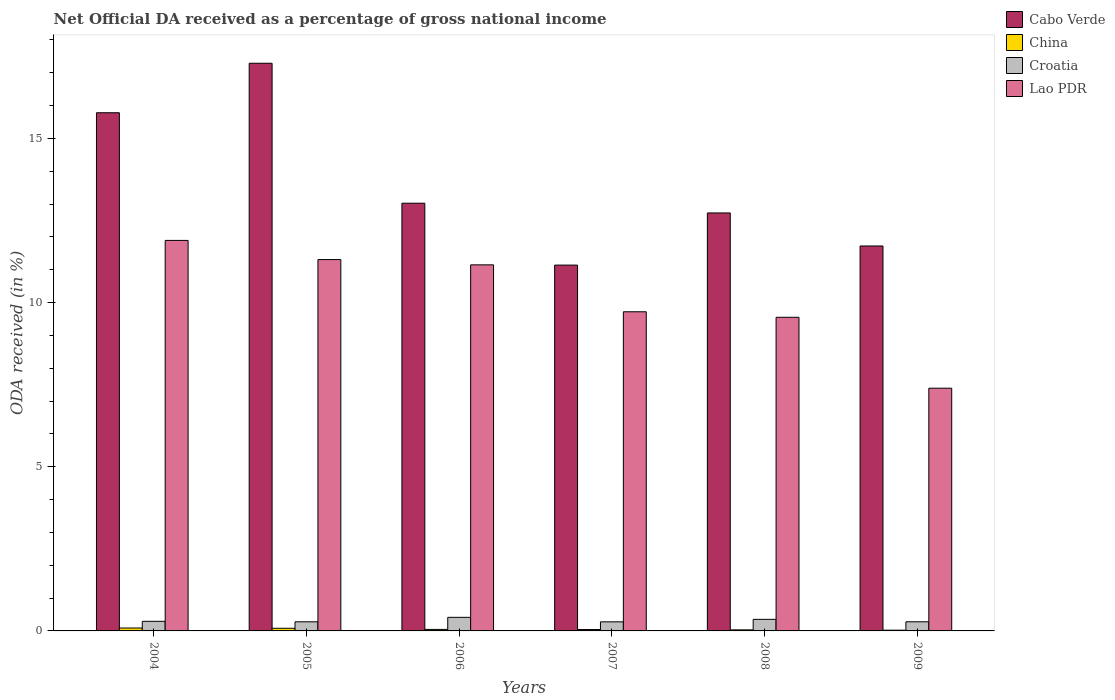How many different coloured bars are there?
Keep it short and to the point. 4. How many groups of bars are there?
Ensure brevity in your answer.  6. Are the number of bars per tick equal to the number of legend labels?
Your answer should be compact. Yes. How many bars are there on the 6th tick from the left?
Keep it short and to the point. 4. How many bars are there on the 3rd tick from the right?
Your response must be concise. 4. What is the label of the 5th group of bars from the left?
Provide a short and direct response. 2008. In how many cases, is the number of bars for a given year not equal to the number of legend labels?
Give a very brief answer. 0. What is the net official DA received in Cabo Verde in 2005?
Your answer should be very brief. 17.29. Across all years, what is the maximum net official DA received in Croatia?
Give a very brief answer. 0.41. Across all years, what is the minimum net official DA received in Croatia?
Offer a terse response. 0.28. What is the total net official DA received in Cabo Verde in the graph?
Keep it short and to the point. 81.69. What is the difference between the net official DA received in Lao PDR in 2006 and that in 2009?
Your answer should be very brief. 3.76. What is the difference between the net official DA received in China in 2005 and the net official DA received in Croatia in 2006?
Your response must be concise. -0.33. What is the average net official DA received in China per year?
Offer a terse response. 0.05. In the year 2004, what is the difference between the net official DA received in Croatia and net official DA received in Lao PDR?
Offer a terse response. -11.6. What is the ratio of the net official DA received in China in 2005 to that in 2008?
Keep it short and to the point. 2.5. Is the difference between the net official DA received in Croatia in 2008 and 2009 greater than the difference between the net official DA received in Lao PDR in 2008 and 2009?
Make the answer very short. No. What is the difference between the highest and the second highest net official DA received in China?
Offer a very short reply. 0.01. What is the difference between the highest and the lowest net official DA received in Lao PDR?
Ensure brevity in your answer.  4.5. In how many years, is the net official DA received in Lao PDR greater than the average net official DA received in Lao PDR taken over all years?
Ensure brevity in your answer.  3. Is the sum of the net official DA received in China in 2005 and 2007 greater than the maximum net official DA received in Lao PDR across all years?
Ensure brevity in your answer.  No. What does the 1st bar from the left in 2007 represents?
Your answer should be compact. Cabo Verde. What does the 4th bar from the right in 2004 represents?
Provide a succinct answer. Cabo Verde. What is the difference between two consecutive major ticks on the Y-axis?
Ensure brevity in your answer.  5. Are the values on the major ticks of Y-axis written in scientific E-notation?
Provide a succinct answer. No. Does the graph contain any zero values?
Make the answer very short. No. Does the graph contain grids?
Provide a short and direct response. No. Where does the legend appear in the graph?
Offer a terse response. Top right. How many legend labels are there?
Your answer should be compact. 4. What is the title of the graph?
Your response must be concise. Net Official DA received as a percentage of gross national income. What is the label or title of the X-axis?
Your response must be concise. Years. What is the label or title of the Y-axis?
Provide a short and direct response. ODA received (in %). What is the ODA received (in %) of Cabo Verde in 2004?
Offer a very short reply. 15.78. What is the ODA received (in %) in China in 2004?
Offer a very short reply. 0.09. What is the ODA received (in %) in Croatia in 2004?
Offer a very short reply. 0.29. What is the ODA received (in %) in Lao PDR in 2004?
Ensure brevity in your answer.  11.89. What is the ODA received (in %) in Cabo Verde in 2005?
Provide a short and direct response. 17.29. What is the ODA received (in %) of China in 2005?
Offer a terse response. 0.08. What is the ODA received (in %) of Croatia in 2005?
Keep it short and to the point. 0.28. What is the ODA received (in %) of Lao PDR in 2005?
Your answer should be compact. 11.31. What is the ODA received (in %) in Cabo Verde in 2006?
Ensure brevity in your answer.  13.03. What is the ODA received (in %) of China in 2006?
Keep it short and to the point. 0.05. What is the ODA received (in %) in Croatia in 2006?
Offer a very short reply. 0.41. What is the ODA received (in %) in Lao PDR in 2006?
Make the answer very short. 11.15. What is the ODA received (in %) in Cabo Verde in 2007?
Provide a short and direct response. 11.14. What is the ODA received (in %) of China in 2007?
Your answer should be compact. 0.04. What is the ODA received (in %) in Croatia in 2007?
Make the answer very short. 0.28. What is the ODA received (in %) in Lao PDR in 2007?
Your answer should be very brief. 9.72. What is the ODA received (in %) in Cabo Verde in 2008?
Offer a very short reply. 12.73. What is the ODA received (in %) in China in 2008?
Make the answer very short. 0.03. What is the ODA received (in %) in Croatia in 2008?
Provide a succinct answer. 0.35. What is the ODA received (in %) in Lao PDR in 2008?
Provide a short and direct response. 9.55. What is the ODA received (in %) of Cabo Verde in 2009?
Offer a very short reply. 11.72. What is the ODA received (in %) in China in 2009?
Your answer should be very brief. 0.02. What is the ODA received (in %) in Croatia in 2009?
Your answer should be very brief. 0.28. What is the ODA received (in %) in Lao PDR in 2009?
Provide a short and direct response. 7.39. Across all years, what is the maximum ODA received (in %) of Cabo Verde?
Offer a very short reply. 17.29. Across all years, what is the maximum ODA received (in %) in China?
Offer a very short reply. 0.09. Across all years, what is the maximum ODA received (in %) of Croatia?
Provide a succinct answer. 0.41. Across all years, what is the maximum ODA received (in %) of Lao PDR?
Provide a succinct answer. 11.89. Across all years, what is the minimum ODA received (in %) of Cabo Verde?
Keep it short and to the point. 11.14. Across all years, what is the minimum ODA received (in %) in China?
Offer a terse response. 0.02. Across all years, what is the minimum ODA received (in %) of Croatia?
Keep it short and to the point. 0.28. Across all years, what is the minimum ODA received (in %) of Lao PDR?
Your answer should be compact. 7.39. What is the total ODA received (in %) in Cabo Verde in the graph?
Ensure brevity in your answer.  81.69. What is the total ODA received (in %) in China in the graph?
Make the answer very short. 0.31. What is the total ODA received (in %) in Croatia in the graph?
Ensure brevity in your answer.  1.89. What is the total ODA received (in %) of Lao PDR in the graph?
Keep it short and to the point. 61.01. What is the difference between the ODA received (in %) of Cabo Verde in 2004 and that in 2005?
Ensure brevity in your answer.  -1.51. What is the difference between the ODA received (in %) in China in 2004 and that in 2005?
Offer a terse response. 0.01. What is the difference between the ODA received (in %) in Croatia in 2004 and that in 2005?
Your answer should be very brief. 0.01. What is the difference between the ODA received (in %) in Lao PDR in 2004 and that in 2005?
Provide a succinct answer. 0.58. What is the difference between the ODA received (in %) in Cabo Verde in 2004 and that in 2006?
Keep it short and to the point. 2.76. What is the difference between the ODA received (in %) in China in 2004 and that in 2006?
Provide a short and direct response. 0.04. What is the difference between the ODA received (in %) of Croatia in 2004 and that in 2006?
Your answer should be very brief. -0.12. What is the difference between the ODA received (in %) in Lao PDR in 2004 and that in 2006?
Keep it short and to the point. 0.74. What is the difference between the ODA received (in %) in Cabo Verde in 2004 and that in 2007?
Provide a succinct answer. 4.64. What is the difference between the ODA received (in %) in China in 2004 and that in 2007?
Keep it short and to the point. 0.05. What is the difference between the ODA received (in %) of Croatia in 2004 and that in 2007?
Provide a succinct answer. 0.02. What is the difference between the ODA received (in %) in Lao PDR in 2004 and that in 2007?
Offer a very short reply. 2.17. What is the difference between the ODA received (in %) of Cabo Verde in 2004 and that in 2008?
Your answer should be very brief. 3.05. What is the difference between the ODA received (in %) of China in 2004 and that in 2008?
Your response must be concise. 0.06. What is the difference between the ODA received (in %) of Croatia in 2004 and that in 2008?
Provide a short and direct response. -0.06. What is the difference between the ODA received (in %) in Lao PDR in 2004 and that in 2008?
Give a very brief answer. 2.34. What is the difference between the ODA received (in %) of Cabo Verde in 2004 and that in 2009?
Your response must be concise. 4.06. What is the difference between the ODA received (in %) of China in 2004 and that in 2009?
Offer a very short reply. 0.07. What is the difference between the ODA received (in %) of Croatia in 2004 and that in 2009?
Offer a very short reply. 0.01. What is the difference between the ODA received (in %) of Lao PDR in 2004 and that in 2009?
Offer a very short reply. 4.5. What is the difference between the ODA received (in %) in Cabo Verde in 2005 and that in 2006?
Give a very brief answer. 4.26. What is the difference between the ODA received (in %) in China in 2005 and that in 2006?
Your answer should be very brief. 0.03. What is the difference between the ODA received (in %) of Croatia in 2005 and that in 2006?
Offer a terse response. -0.14. What is the difference between the ODA received (in %) in Lao PDR in 2005 and that in 2006?
Give a very brief answer. 0.16. What is the difference between the ODA received (in %) in Cabo Verde in 2005 and that in 2007?
Your answer should be compact. 6.15. What is the difference between the ODA received (in %) of China in 2005 and that in 2007?
Offer a terse response. 0.04. What is the difference between the ODA received (in %) of Lao PDR in 2005 and that in 2007?
Keep it short and to the point. 1.59. What is the difference between the ODA received (in %) in Cabo Verde in 2005 and that in 2008?
Make the answer very short. 4.56. What is the difference between the ODA received (in %) in China in 2005 and that in 2008?
Provide a succinct answer. 0.05. What is the difference between the ODA received (in %) in Croatia in 2005 and that in 2008?
Your response must be concise. -0.07. What is the difference between the ODA received (in %) in Lao PDR in 2005 and that in 2008?
Make the answer very short. 1.76. What is the difference between the ODA received (in %) in Cabo Verde in 2005 and that in 2009?
Your answer should be compact. 5.56. What is the difference between the ODA received (in %) of China in 2005 and that in 2009?
Your answer should be compact. 0.06. What is the difference between the ODA received (in %) in Croatia in 2005 and that in 2009?
Offer a very short reply. -0. What is the difference between the ODA received (in %) in Lao PDR in 2005 and that in 2009?
Give a very brief answer. 3.92. What is the difference between the ODA received (in %) of Cabo Verde in 2006 and that in 2007?
Give a very brief answer. 1.89. What is the difference between the ODA received (in %) in China in 2006 and that in 2007?
Offer a terse response. 0. What is the difference between the ODA received (in %) of Croatia in 2006 and that in 2007?
Your answer should be very brief. 0.14. What is the difference between the ODA received (in %) in Lao PDR in 2006 and that in 2007?
Provide a short and direct response. 1.43. What is the difference between the ODA received (in %) in Cabo Verde in 2006 and that in 2008?
Make the answer very short. 0.3. What is the difference between the ODA received (in %) of China in 2006 and that in 2008?
Keep it short and to the point. 0.01. What is the difference between the ODA received (in %) of Croatia in 2006 and that in 2008?
Ensure brevity in your answer.  0.06. What is the difference between the ODA received (in %) in Lao PDR in 2006 and that in 2008?
Give a very brief answer. 1.6. What is the difference between the ODA received (in %) of Cabo Verde in 2006 and that in 2009?
Provide a succinct answer. 1.3. What is the difference between the ODA received (in %) of China in 2006 and that in 2009?
Keep it short and to the point. 0.02. What is the difference between the ODA received (in %) of Croatia in 2006 and that in 2009?
Give a very brief answer. 0.14. What is the difference between the ODA received (in %) in Lao PDR in 2006 and that in 2009?
Give a very brief answer. 3.76. What is the difference between the ODA received (in %) in Cabo Verde in 2007 and that in 2008?
Keep it short and to the point. -1.59. What is the difference between the ODA received (in %) in China in 2007 and that in 2008?
Give a very brief answer. 0.01. What is the difference between the ODA received (in %) of Croatia in 2007 and that in 2008?
Offer a terse response. -0.08. What is the difference between the ODA received (in %) in Lao PDR in 2007 and that in 2008?
Make the answer very short. 0.17. What is the difference between the ODA received (in %) of Cabo Verde in 2007 and that in 2009?
Provide a succinct answer. -0.58. What is the difference between the ODA received (in %) in China in 2007 and that in 2009?
Keep it short and to the point. 0.02. What is the difference between the ODA received (in %) in Croatia in 2007 and that in 2009?
Ensure brevity in your answer.  -0. What is the difference between the ODA received (in %) in Lao PDR in 2007 and that in 2009?
Offer a very short reply. 2.33. What is the difference between the ODA received (in %) in Cabo Verde in 2008 and that in 2009?
Offer a very short reply. 1.01. What is the difference between the ODA received (in %) in China in 2008 and that in 2009?
Offer a very short reply. 0.01. What is the difference between the ODA received (in %) of Croatia in 2008 and that in 2009?
Your answer should be compact. 0.07. What is the difference between the ODA received (in %) in Lao PDR in 2008 and that in 2009?
Your response must be concise. 2.16. What is the difference between the ODA received (in %) in Cabo Verde in 2004 and the ODA received (in %) in China in 2005?
Your answer should be compact. 15.7. What is the difference between the ODA received (in %) in Cabo Verde in 2004 and the ODA received (in %) in Croatia in 2005?
Keep it short and to the point. 15.5. What is the difference between the ODA received (in %) of Cabo Verde in 2004 and the ODA received (in %) of Lao PDR in 2005?
Your answer should be compact. 4.47. What is the difference between the ODA received (in %) of China in 2004 and the ODA received (in %) of Croatia in 2005?
Make the answer very short. -0.19. What is the difference between the ODA received (in %) in China in 2004 and the ODA received (in %) in Lao PDR in 2005?
Give a very brief answer. -11.22. What is the difference between the ODA received (in %) in Croatia in 2004 and the ODA received (in %) in Lao PDR in 2005?
Ensure brevity in your answer.  -11.02. What is the difference between the ODA received (in %) of Cabo Verde in 2004 and the ODA received (in %) of China in 2006?
Make the answer very short. 15.74. What is the difference between the ODA received (in %) in Cabo Verde in 2004 and the ODA received (in %) in Croatia in 2006?
Provide a succinct answer. 15.37. What is the difference between the ODA received (in %) in Cabo Verde in 2004 and the ODA received (in %) in Lao PDR in 2006?
Offer a terse response. 4.63. What is the difference between the ODA received (in %) in China in 2004 and the ODA received (in %) in Croatia in 2006?
Offer a very short reply. -0.33. What is the difference between the ODA received (in %) in China in 2004 and the ODA received (in %) in Lao PDR in 2006?
Offer a terse response. -11.06. What is the difference between the ODA received (in %) in Croatia in 2004 and the ODA received (in %) in Lao PDR in 2006?
Keep it short and to the point. -10.86. What is the difference between the ODA received (in %) in Cabo Verde in 2004 and the ODA received (in %) in China in 2007?
Your answer should be very brief. 15.74. What is the difference between the ODA received (in %) in Cabo Verde in 2004 and the ODA received (in %) in Croatia in 2007?
Your answer should be very brief. 15.5. What is the difference between the ODA received (in %) of Cabo Verde in 2004 and the ODA received (in %) of Lao PDR in 2007?
Offer a very short reply. 6.06. What is the difference between the ODA received (in %) in China in 2004 and the ODA received (in %) in Croatia in 2007?
Ensure brevity in your answer.  -0.19. What is the difference between the ODA received (in %) in China in 2004 and the ODA received (in %) in Lao PDR in 2007?
Offer a terse response. -9.63. What is the difference between the ODA received (in %) in Croatia in 2004 and the ODA received (in %) in Lao PDR in 2007?
Offer a very short reply. -9.43. What is the difference between the ODA received (in %) of Cabo Verde in 2004 and the ODA received (in %) of China in 2008?
Ensure brevity in your answer.  15.75. What is the difference between the ODA received (in %) in Cabo Verde in 2004 and the ODA received (in %) in Croatia in 2008?
Give a very brief answer. 15.43. What is the difference between the ODA received (in %) of Cabo Verde in 2004 and the ODA received (in %) of Lao PDR in 2008?
Ensure brevity in your answer.  6.23. What is the difference between the ODA received (in %) in China in 2004 and the ODA received (in %) in Croatia in 2008?
Provide a succinct answer. -0.26. What is the difference between the ODA received (in %) of China in 2004 and the ODA received (in %) of Lao PDR in 2008?
Ensure brevity in your answer.  -9.46. What is the difference between the ODA received (in %) of Croatia in 2004 and the ODA received (in %) of Lao PDR in 2008?
Provide a short and direct response. -9.26. What is the difference between the ODA received (in %) of Cabo Verde in 2004 and the ODA received (in %) of China in 2009?
Ensure brevity in your answer.  15.76. What is the difference between the ODA received (in %) in Cabo Verde in 2004 and the ODA received (in %) in Croatia in 2009?
Your answer should be compact. 15.5. What is the difference between the ODA received (in %) in Cabo Verde in 2004 and the ODA received (in %) in Lao PDR in 2009?
Make the answer very short. 8.39. What is the difference between the ODA received (in %) of China in 2004 and the ODA received (in %) of Croatia in 2009?
Your answer should be compact. -0.19. What is the difference between the ODA received (in %) in China in 2004 and the ODA received (in %) in Lao PDR in 2009?
Provide a short and direct response. -7.3. What is the difference between the ODA received (in %) in Croatia in 2004 and the ODA received (in %) in Lao PDR in 2009?
Provide a succinct answer. -7.1. What is the difference between the ODA received (in %) in Cabo Verde in 2005 and the ODA received (in %) in China in 2006?
Your answer should be compact. 17.24. What is the difference between the ODA received (in %) of Cabo Verde in 2005 and the ODA received (in %) of Croatia in 2006?
Give a very brief answer. 16.87. What is the difference between the ODA received (in %) of Cabo Verde in 2005 and the ODA received (in %) of Lao PDR in 2006?
Your response must be concise. 6.14. What is the difference between the ODA received (in %) of China in 2005 and the ODA received (in %) of Croatia in 2006?
Your answer should be very brief. -0.33. What is the difference between the ODA received (in %) of China in 2005 and the ODA received (in %) of Lao PDR in 2006?
Keep it short and to the point. -11.07. What is the difference between the ODA received (in %) in Croatia in 2005 and the ODA received (in %) in Lao PDR in 2006?
Your response must be concise. -10.87. What is the difference between the ODA received (in %) of Cabo Verde in 2005 and the ODA received (in %) of China in 2007?
Your answer should be compact. 17.25. What is the difference between the ODA received (in %) of Cabo Verde in 2005 and the ODA received (in %) of Croatia in 2007?
Offer a very short reply. 17.01. What is the difference between the ODA received (in %) in Cabo Verde in 2005 and the ODA received (in %) in Lao PDR in 2007?
Your response must be concise. 7.57. What is the difference between the ODA received (in %) in China in 2005 and the ODA received (in %) in Croatia in 2007?
Keep it short and to the point. -0.2. What is the difference between the ODA received (in %) in China in 2005 and the ODA received (in %) in Lao PDR in 2007?
Your answer should be very brief. -9.64. What is the difference between the ODA received (in %) in Croatia in 2005 and the ODA received (in %) in Lao PDR in 2007?
Keep it short and to the point. -9.44. What is the difference between the ODA received (in %) in Cabo Verde in 2005 and the ODA received (in %) in China in 2008?
Your answer should be very brief. 17.26. What is the difference between the ODA received (in %) in Cabo Verde in 2005 and the ODA received (in %) in Croatia in 2008?
Make the answer very short. 16.94. What is the difference between the ODA received (in %) of Cabo Verde in 2005 and the ODA received (in %) of Lao PDR in 2008?
Offer a terse response. 7.74. What is the difference between the ODA received (in %) in China in 2005 and the ODA received (in %) in Croatia in 2008?
Provide a succinct answer. -0.27. What is the difference between the ODA received (in %) of China in 2005 and the ODA received (in %) of Lao PDR in 2008?
Your answer should be very brief. -9.47. What is the difference between the ODA received (in %) of Croatia in 2005 and the ODA received (in %) of Lao PDR in 2008?
Keep it short and to the point. -9.27. What is the difference between the ODA received (in %) in Cabo Verde in 2005 and the ODA received (in %) in China in 2009?
Your response must be concise. 17.27. What is the difference between the ODA received (in %) in Cabo Verde in 2005 and the ODA received (in %) in Croatia in 2009?
Provide a succinct answer. 17.01. What is the difference between the ODA received (in %) in Cabo Verde in 2005 and the ODA received (in %) in Lao PDR in 2009?
Your answer should be very brief. 9.9. What is the difference between the ODA received (in %) of China in 2005 and the ODA received (in %) of Croatia in 2009?
Ensure brevity in your answer.  -0.2. What is the difference between the ODA received (in %) of China in 2005 and the ODA received (in %) of Lao PDR in 2009?
Provide a succinct answer. -7.31. What is the difference between the ODA received (in %) in Croatia in 2005 and the ODA received (in %) in Lao PDR in 2009?
Provide a succinct answer. -7.11. What is the difference between the ODA received (in %) of Cabo Verde in 2006 and the ODA received (in %) of China in 2007?
Your answer should be very brief. 12.98. What is the difference between the ODA received (in %) in Cabo Verde in 2006 and the ODA received (in %) in Croatia in 2007?
Your response must be concise. 12.75. What is the difference between the ODA received (in %) in Cabo Verde in 2006 and the ODA received (in %) in Lao PDR in 2007?
Make the answer very short. 3.31. What is the difference between the ODA received (in %) of China in 2006 and the ODA received (in %) of Croatia in 2007?
Make the answer very short. -0.23. What is the difference between the ODA received (in %) of China in 2006 and the ODA received (in %) of Lao PDR in 2007?
Provide a succinct answer. -9.67. What is the difference between the ODA received (in %) of Croatia in 2006 and the ODA received (in %) of Lao PDR in 2007?
Your answer should be very brief. -9.31. What is the difference between the ODA received (in %) of Cabo Verde in 2006 and the ODA received (in %) of China in 2008?
Give a very brief answer. 12.99. What is the difference between the ODA received (in %) of Cabo Verde in 2006 and the ODA received (in %) of Croatia in 2008?
Offer a terse response. 12.67. What is the difference between the ODA received (in %) of Cabo Verde in 2006 and the ODA received (in %) of Lao PDR in 2008?
Your answer should be compact. 3.47. What is the difference between the ODA received (in %) of China in 2006 and the ODA received (in %) of Croatia in 2008?
Give a very brief answer. -0.31. What is the difference between the ODA received (in %) of China in 2006 and the ODA received (in %) of Lao PDR in 2008?
Give a very brief answer. -9.51. What is the difference between the ODA received (in %) of Croatia in 2006 and the ODA received (in %) of Lao PDR in 2008?
Keep it short and to the point. -9.14. What is the difference between the ODA received (in %) in Cabo Verde in 2006 and the ODA received (in %) in China in 2009?
Provide a succinct answer. 13. What is the difference between the ODA received (in %) in Cabo Verde in 2006 and the ODA received (in %) in Croatia in 2009?
Your answer should be compact. 12.75. What is the difference between the ODA received (in %) in Cabo Verde in 2006 and the ODA received (in %) in Lao PDR in 2009?
Keep it short and to the point. 5.63. What is the difference between the ODA received (in %) of China in 2006 and the ODA received (in %) of Croatia in 2009?
Provide a succinct answer. -0.23. What is the difference between the ODA received (in %) in China in 2006 and the ODA received (in %) in Lao PDR in 2009?
Your response must be concise. -7.35. What is the difference between the ODA received (in %) of Croatia in 2006 and the ODA received (in %) of Lao PDR in 2009?
Your response must be concise. -6.98. What is the difference between the ODA received (in %) in Cabo Verde in 2007 and the ODA received (in %) in China in 2008?
Your answer should be compact. 11.11. What is the difference between the ODA received (in %) in Cabo Verde in 2007 and the ODA received (in %) in Croatia in 2008?
Offer a very short reply. 10.79. What is the difference between the ODA received (in %) of Cabo Verde in 2007 and the ODA received (in %) of Lao PDR in 2008?
Your response must be concise. 1.59. What is the difference between the ODA received (in %) in China in 2007 and the ODA received (in %) in Croatia in 2008?
Ensure brevity in your answer.  -0.31. What is the difference between the ODA received (in %) of China in 2007 and the ODA received (in %) of Lao PDR in 2008?
Provide a short and direct response. -9.51. What is the difference between the ODA received (in %) in Croatia in 2007 and the ODA received (in %) in Lao PDR in 2008?
Keep it short and to the point. -9.28. What is the difference between the ODA received (in %) of Cabo Verde in 2007 and the ODA received (in %) of China in 2009?
Provide a succinct answer. 11.12. What is the difference between the ODA received (in %) of Cabo Verde in 2007 and the ODA received (in %) of Croatia in 2009?
Offer a terse response. 10.86. What is the difference between the ODA received (in %) of Cabo Verde in 2007 and the ODA received (in %) of Lao PDR in 2009?
Give a very brief answer. 3.75. What is the difference between the ODA received (in %) of China in 2007 and the ODA received (in %) of Croatia in 2009?
Your response must be concise. -0.24. What is the difference between the ODA received (in %) of China in 2007 and the ODA received (in %) of Lao PDR in 2009?
Keep it short and to the point. -7.35. What is the difference between the ODA received (in %) in Croatia in 2007 and the ODA received (in %) in Lao PDR in 2009?
Keep it short and to the point. -7.12. What is the difference between the ODA received (in %) of Cabo Verde in 2008 and the ODA received (in %) of China in 2009?
Your answer should be compact. 12.71. What is the difference between the ODA received (in %) of Cabo Verde in 2008 and the ODA received (in %) of Croatia in 2009?
Offer a terse response. 12.45. What is the difference between the ODA received (in %) in Cabo Verde in 2008 and the ODA received (in %) in Lao PDR in 2009?
Ensure brevity in your answer.  5.34. What is the difference between the ODA received (in %) of China in 2008 and the ODA received (in %) of Croatia in 2009?
Your response must be concise. -0.25. What is the difference between the ODA received (in %) of China in 2008 and the ODA received (in %) of Lao PDR in 2009?
Give a very brief answer. -7.36. What is the difference between the ODA received (in %) in Croatia in 2008 and the ODA received (in %) in Lao PDR in 2009?
Ensure brevity in your answer.  -7.04. What is the average ODA received (in %) in Cabo Verde per year?
Make the answer very short. 13.62. What is the average ODA received (in %) of China per year?
Offer a very short reply. 0.05. What is the average ODA received (in %) of Croatia per year?
Ensure brevity in your answer.  0.32. What is the average ODA received (in %) in Lao PDR per year?
Ensure brevity in your answer.  10.17. In the year 2004, what is the difference between the ODA received (in %) in Cabo Verde and ODA received (in %) in China?
Your answer should be very brief. 15.69. In the year 2004, what is the difference between the ODA received (in %) of Cabo Verde and ODA received (in %) of Croatia?
Offer a terse response. 15.49. In the year 2004, what is the difference between the ODA received (in %) in Cabo Verde and ODA received (in %) in Lao PDR?
Provide a succinct answer. 3.89. In the year 2004, what is the difference between the ODA received (in %) of China and ODA received (in %) of Croatia?
Offer a terse response. -0.2. In the year 2004, what is the difference between the ODA received (in %) in China and ODA received (in %) in Lao PDR?
Offer a terse response. -11.8. In the year 2004, what is the difference between the ODA received (in %) in Croatia and ODA received (in %) in Lao PDR?
Make the answer very short. -11.6. In the year 2005, what is the difference between the ODA received (in %) of Cabo Verde and ODA received (in %) of China?
Offer a terse response. 17.21. In the year 2005, what is the difference between the ODA received (in %) in Cabo Verde and ODA received (in %) in Croatia?
Provide a short and direct response. 17.01. In the year 2005, what is the difference between the ODA received (in %) of Cabo Verde and ODA received (in %) of Lao PDR?
Make the answer very short. 5.98. In the year 2005, what is the difference between the ODA received (in %) of China and ODA received (in %) of Croatia?
Ensure brevity in your answer.  -0.2. In the year 2005, what is the difference between the ODA received (in %) in China and ODA received (in %) in Lao PDR?
Offer a very short reply. -11.23. In the year 2005, what is the difference between the ODA received (in %) of Croatia and ODA received (in %) of Lao PDR?
Keep it short and to the point. -11.03. In the year 2006, what is the difference between the ODA received (in %) in Cabo Verde and ODA received (in %) in China?
Provide a succinct answer. 12.98. In the year 2006, what is the difference between the ODA received (in %) in Cabo Verde and ODA received (in %) in Croatia?
Provide a short and direct response. 12.61. In the year 2006, what is the difference between the ODA received (in %) in Cabo Verde and ODA received (in %) in Lao PDR?
Your answer should be compact. 1.88. In the year 2006, what is the difference between the ODA received (in %) in China and ODA received (in %) in Croatia?
Ensure brevity in your answer.  -0.37. In the year 2006, what is the difference between the ODA received (in %) of China and ODA received (in %) of Lao PDR?
Your answer should be very brief. -11.1. In the year 2006, what is the difference between the ODA received (in %) of Croatia and ODA received (in %) of Lao PDR?
Provide a short and direct response. -10.74. In the year 2007, what is the difference between the ODA received (in %) of Cabo Verde and ODA received (in %) of China?
Provide a short and direct response. 11.1. In the year 2007, what is the difference between the ODA received (in %) in Cabo Verde and ODA received (in %) in Croatia?
Provide a succinct answer. 10.86. In the year 2007, what is the difference between the ODA received (in %) of Cabo Verde and ODA received (in %) of Lao PDR?
Give a very brief answer. 1.42. In the year 2007, what is the difference between the ODA received (in %) of China and ODA received (in %) of Croatia?
Offer a terse response. -0.23. In the year 2007, what is the difference between the ODA received (in %) of China and ODA received (in %) of Lao PDR?
Make the answer very short. -9.68. In the year 2007, what is the difference between the ODA received (in %) in Croatia and ODA received (in %) in Lao PDR?
Provide a succinct answer. -9.44. In the year 2008, what is the difference between the ODA received (in %) in Cabo Verde and ODA received (in %) in China?
Your answer should be compact. 12.7. In the year 2008, what is the difference between the ODA received (in %) in Cabo Verde and ODA received (in %) in Croatia?
Your answer should be very brief. 12.38. In the year 2008, what is the difference between the ODA received (in %) of Cabo Verde and ODA received (in %) of Lao PDR?
Your answer should be compact. 3.18. In the year 2008, what is the difference between the ODA received (in %) in China and ODA received (in %) in Croatia?
Offer a very short reply. -0.32. In the year 2008, what is the difference between the ODA received (in %) of China and ODA received (in %) of Lao PDR?
Provide a short and direct response. -9.52. In the year 2008, what is the difference between the ODA received (in %) in Croatia and ODA received (in %) in Lao PDR?
Provide a short and direct response. -9.2. In the year 2009, what is the difference between the ODA received (in %) of Cabo Verde and ODA received (in %) of China?
Ensure brevity in your answer.  11.7. In the year 2009, what is the difference between the ODA received (in %) of Cabo Verde and ODA received (in %) of Croatia?
Ensure brevity in your answer.  11.45. In the year 2009, what is the difference between the ODA received (in %) in Cabo Verde and ODA received (in %) in Lao PDR?
Ensure brevity in your answer.  4.33. In the year 2009, what is the difference between the ODA received (in %) in China and ODA received (in %) in Croatia?
Make the answer very short. -0.26. In the year 2009, what is the difference between the ODA received (in %) in China and ODA received (in %) in Lao PDR?
Your answer should be very brief. -7.37. In the year 2009, what is the difference between the ODA received (in %) in Croatia and ODA received (in %) in Lao PDR?
Provide a short and direct response. -7.11. What is the ratio of the ODA received (in %) of Cabo Verde in 2004 to that in 2005?
Provide a succinct answer. 0.91. What is the ratio of the ODA received (in %) of China in 2004 to that in 2005?
Offer a very short reply. 1.1. What is the ratio of the ODA received (in %) in Croatia in 2004 to that in 2005?
Your response must be concise. 1.05. What is the ratio of the ODA received (in %) of Lao PDR in 2004 to that in 2005?
Ensure brevity in your answer.  1.05. What is the ratio of the ODA received (in %) in Cabo Verde in 2004 to that in 2006?
Your response must be concise. 1.21. What is the ratio of the ODA received (in %) of China in 2004 to that in 2006?
Your response must be concise. 1.93. What is the ratio of the ODA received (in %) in Croatia in 2004 to that in 2006?
Provide a short and direct response. 0.71. What is the ratio of the ODA received (in %) of Lao PDR in 2004 to that in 2006?
Offer a very short reply. 1.07. What is the ratio of the ODA received (in %) of Cabo Verde in 2004 to that in 2007?
Offer a terse response. 1.42. What is the ratio of the ODA received (in %) of China in 2004 to that in 2007?
Your response must be concise. 2.1. What is the ratio of the ODA received (in %) of Croatia in 2004 to that in 2007?
Ensure brevity in your answer.  1.06. What is the ratio of the ODA received (in %) of Lao PDR in 2004 to that in 2007?
Offer a very short reply. 1.22. What is the ratio of the ODA received (in %) in Cabo Verde in 2004 to that in 2008?
Make the answer very short. 1.24. What is the ratio of the ODA received (in %) in China in 2004 to that in 2008?
Your response must be concise. 2.75. What is the ratio of the ODA received (in %) in Croatia in 2004 to that in 2008?
Your response must be concise. 0.83. What is the ratio of the ODA received (in %) of Lao PDR in 2004 to that in 2008?
Your response must be concise. 1.25. What is the ratio of the ODA received (in %) in Cabo Verde in 2004 to that in 2009?
Offer a terse response. 1.35. What is the ratio of the ODA received (in %) of China in 2004 to that in 2009?
Offer a very short reply. 3.96. What is the ratio of the ODA received (in %) in Croatia in 2004 to that in 2009?
Provide a succinct answer. 1.05. What is the ratio of the ODA received (in %) in Lao PDR in 2004 to that in 2009?
Your answer should be very brief. 1.61. What is the ratio of the ODA received (in %) in Cabo Verde in 2005 to that in 2006?
Offer a very short reply. 1.33. What is the ratio of the ODA received (in %) of China in 2005 to that in 2006?
Your answer should be compact. 1.76. What is the ratio of the ODA received (in %) in Croatia in 2005 to that in 2006?
Your answer should be compact. 0.67. What is the ratio of the ODA received (in %) of Lao PDR in 2005 to that in 2006?
Provide a succinct answer. 1.01. What is the ratio of the ODA received (in %) in Cabo Verde in 2005 to that in 2007?
Offer a very short reply. 1.55. What is the ratio of the ODA received (in %) in China in 2005 to that in 2007?
Your answer should be very brief. 1.91. What is the ratio of the ODA received (in %) of Lao PDR in 2005 to that in 2007?
Make the answer very short. 1.16. What is the ratio of the ODA received (in %) of Cabo Verde in 2005 to that in 2008?
Keep it short and to the point. 1.36. What is the ratio of the ODA received (in %) of China in 2005 to that in 2008?
Offer a terse response. 2.5. What is the ratio of the ODA received (in %) of Croatia in 2005 to that in 2008?
Keep it short and to the point. 0.79. What is the ratio of the ODA received (in %) in Lao PDR in 2005 to that in 2008?
Your response must be concise. 1.18. What is the ratio of the ODA received (in %) of Cabo Verde in 2005 to that in 2009?
Give a very brief answer. 1.47. What is the ratio of the ODA received (in %) of China in 2005 to that in 2009?
Your response must be concise. 3.6. What is the ratio of the ODA received (in %) of Croatia in 2005 to that in 2009?
Provide a short and direct response. 1. What is the ratio of the ODA received (in %) in Lao PDR in 2005 to that in 2009?
Offer a very short reply. 1.53. What is the ratio of the ODA received (in %) in Cabo Verde in 2006 to that in 2007?
Give a very brief answer. 1.17. What is the ratio of the ODA received (in %) of China in 2006 to that in 2007?
Provide a succinct answer. 1.09. What is the ratio of the ODA received (in %) in Croatia in 2006 to that in 2007?
Offer a very short reply. 1.49. What is the ratio of the ODA received (in %) in Lao PDR in 2006 to that in 2007?
Your answer should be compact. 1.15. What is the ratio of the ODA received (in %) in Cabo Verde in 2006 to that in 2008?
Your answer should be compact. 1.02. What is the ratio of the ODA received (in %) in China in 2006 to that in 2008?
Your answer should be compact. 1.42. What is the ratio of the ODA received (in %) in Croatia in 2006 to that in 2008?
Provide a short and direct response. 1.17. What is the ratio of the ODA received (in %) of Lao PDR in 2006 to that in 2008?
Keep it short and to the point. 1.17. What is the ratio of the ODA received (in %) of China in 2006 to that in 2009?
Give a very brief answer. 2.05. What is the ratio of the ODA received (in %) of Croatia in 2006 to that in 2009?
Give a very brief answer. 1.49. What is the ratio of the ODA received (in %) of Lao PDR in 2006 to that in 2009?
Give a very brief answer. 1.51. What is the ratio of the ODA received (in %) of Cabo Verde in 2007 to that in 2008?
Offer a very short reply. 0.88. What is the ratio of the ODA received (in %) of China in 2007 to that in 2008?
Your answer should be compact. 1.31. What is the ratio of the ODA received (in %) in Croatia in 2007 to that in 2008?
Your response must be concise. 0.79. What is the ratio of the ODA received (in %) of Lao PDR in 2007 to that in 2008?
Your response must be concise. 1.02. What is the ratio of the ODA received (in %) in Cabo Verde in 2007 to that in 2009?
Keep it short and to the point. 0.95. What is the ratio of the ODA received (in %) in China in 2007 to that in 2009?
Keep it short and to the point. 1.88. What is the ratio of the ODA received (in %) of Lao PDR in 2007 to that in 2009?
Offer a very short reply. 1.31. What is the ratio of the ODA received (in %) of Cabo Verde in 2008 to that in 2009?
Make the answer very short. 1.09. What is the ratio of the ODA received (in %) of China in 2008 to that in 2009?
Provide a succinct answer. 1.44. What is the ratio of the ODA received (in %) of Croatia in 2008 to that in 2009?
Give a very brief answer. 1.27. What is the ratio of the ODA received (in %) in Lao PDR in 2008 to that in 2009?
Your response must be concise. 1.29. What is the difference between the highest and the second highest ODA received (in %) in Cabo Verde?
Your response must be concise. 1.51. What is the difference between the highest and the second highest ODA received (in %) of China?
Provide a short and direct response. 0.01. What is the difference between the highest and the second highest ODA received (in %) in Croatia?
Keep it short and to the point. 0.06. What is the difference between the highest and the second highest ODA received (in %) of Lao PDR?
Offer a terse response. 0.58. What is the difference between the highest and the lowest ODA received (in %) of Cabo Verde?
Offer a very short reply. 6.15. What is the difference between the highest and the lowest ODA received (in %) in China?
Give a very brief answer. 0.07. What is the difference between the highest and the lowest ODA received (in %) of Croatia?
Your response must be concise. 0.14. What is the difference between the highest and the lowest ODA received (in %) of Lao PDR?
Your answer should be compact. 4.5. 